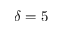Convert formula to latex. <formula><loc_0><loc_0><loc_500><loc_500>\delta = 5</formula> 